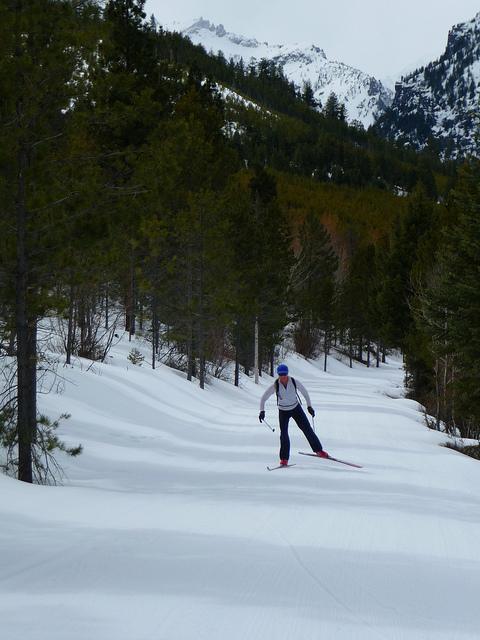How does the weather feel, most likely?
Answer briefly. Cold. Is this a selfie?
Write a very short answer. No. Does it seem that this forested region has a lot of new growth?
Give a very brief answer. Yes. Are they slalom skiing?
Write a very short answer. No. How many skiers are in the photo?
Quick response, please. 1. Is this cross country skiing?
Be succinct. Yes. 